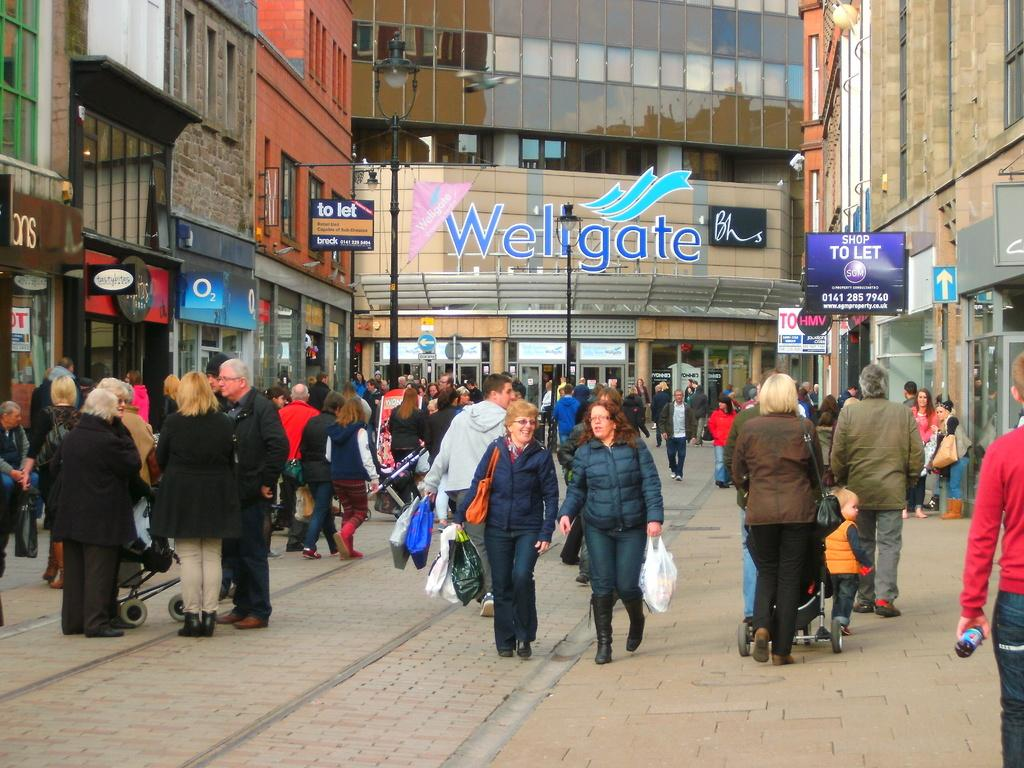What is happening in the image? There are people standing in the image. What can be seen on either side of the people? There are stores on either side of the people. What is visible in the background of the image? There is a building in the background of the image. What type of representative can be seen in the image? There is no representative present in the image; it features people standing near stores with a building in the background. 